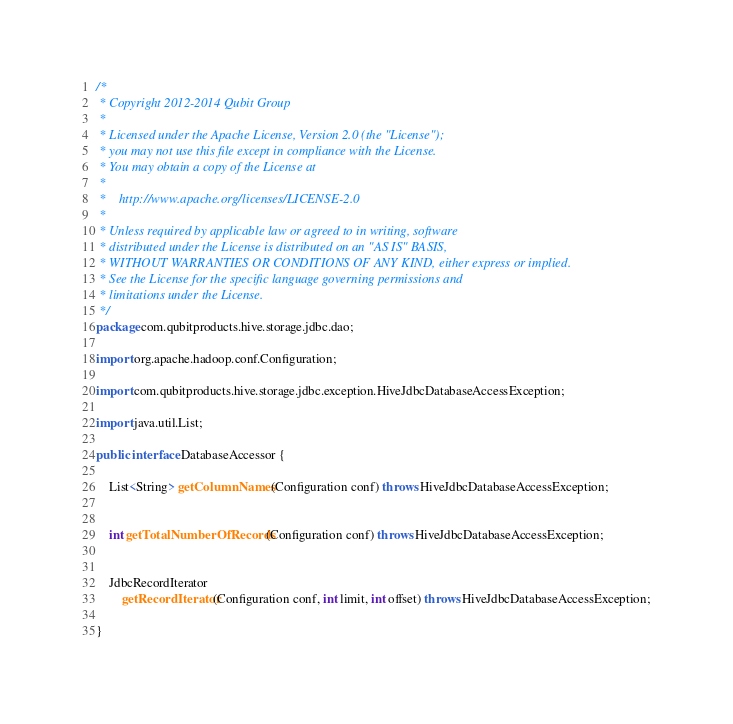Convert code to text. <code><loc_0><loc_0><loc_500><loc_500><_Java_>/*
 * Copyright 2012-2014 Qubit Group
 *
 * Licensed under the Apache License, Version 2.0 (the "License");
 * you may not use this file except in compliance with the License.
 * You may obtain a copy of the License at
 *
 *    http://www.apache.org/licenses/LICENSE-2.0
 *
 * Unless required by applicable law or agreed to in writing, software
 * distributed under the License is distributed on an "AS IS" BASIS,
 * WITHOUT WARRANTIES OR CONDITIONS OF ANY KIND, either express or implied.
 * See the License for the specific language governing permissions and
 * limitations under the License.
 */
package com.qubitproducts.hive.storage.jdbc.dao;

import org.apache.hadoop.conf.Configuration;

import com.qubitproducts.hive.storage.jdbc.exception.HiveJdbcDatabaseAccessException;

import java.util.List;

public interface DatabaseAccessor {

    List<String> getColumnNames(Configuration conf) throws HiveJdbcDatabaseAccessException;


    int getTotalNumberOfRecords(Configuration conf) throws HiveJdbcDatabaseAccessException;


    JdbcRecordIterator
        getRecordIterator(Configuration conf, int limit, int offset) throws HiveJdbcDatabaseAccessException;

}
</code> 